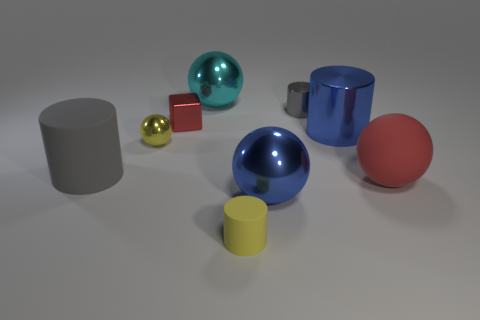Add 1 big matte balls. How many objects exist? 10 Subtract all cylinders. How many objects are left? 5 Add 2 big red matte things. How many big red matte things are left? 3 Add 3 metal cylinders. How many metal cylinders exist? 5 Subtract 0 gray blocks. How many objects are left? 9 Subtract all yellow cylinders. Subtract all rubber cylinders. How many objects are left? 6 